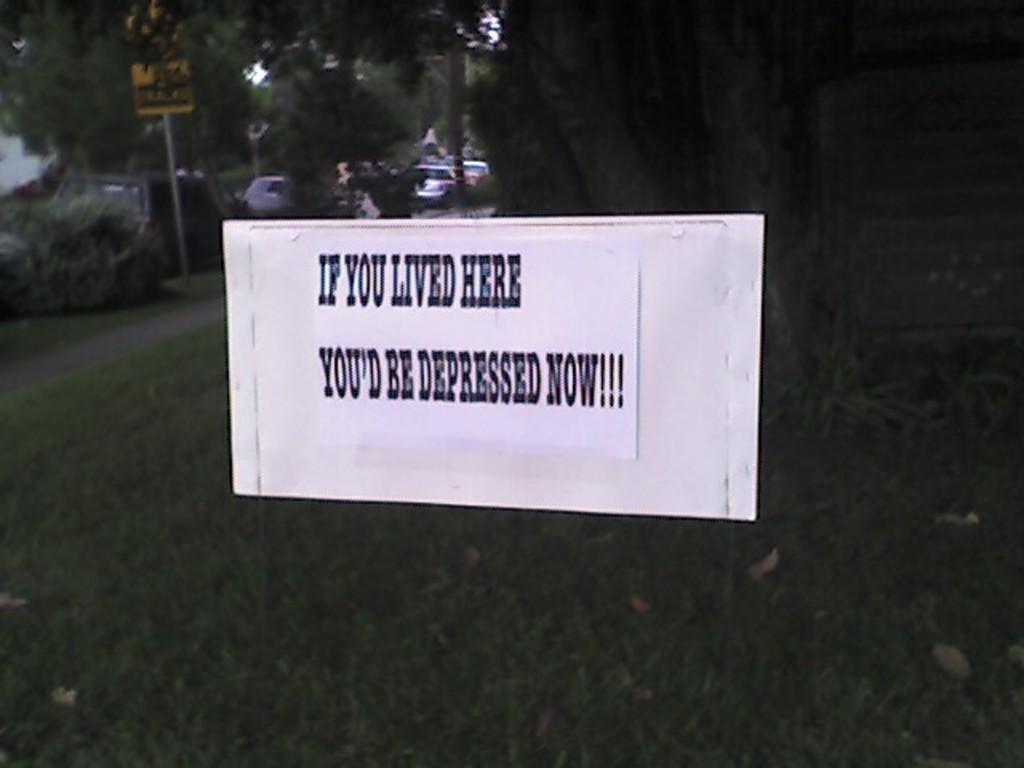Please provide a concise description of this image. Here I can see a white color board on which I can see some text. In the background there are some trees and the grass and also there are few cars on the road. 